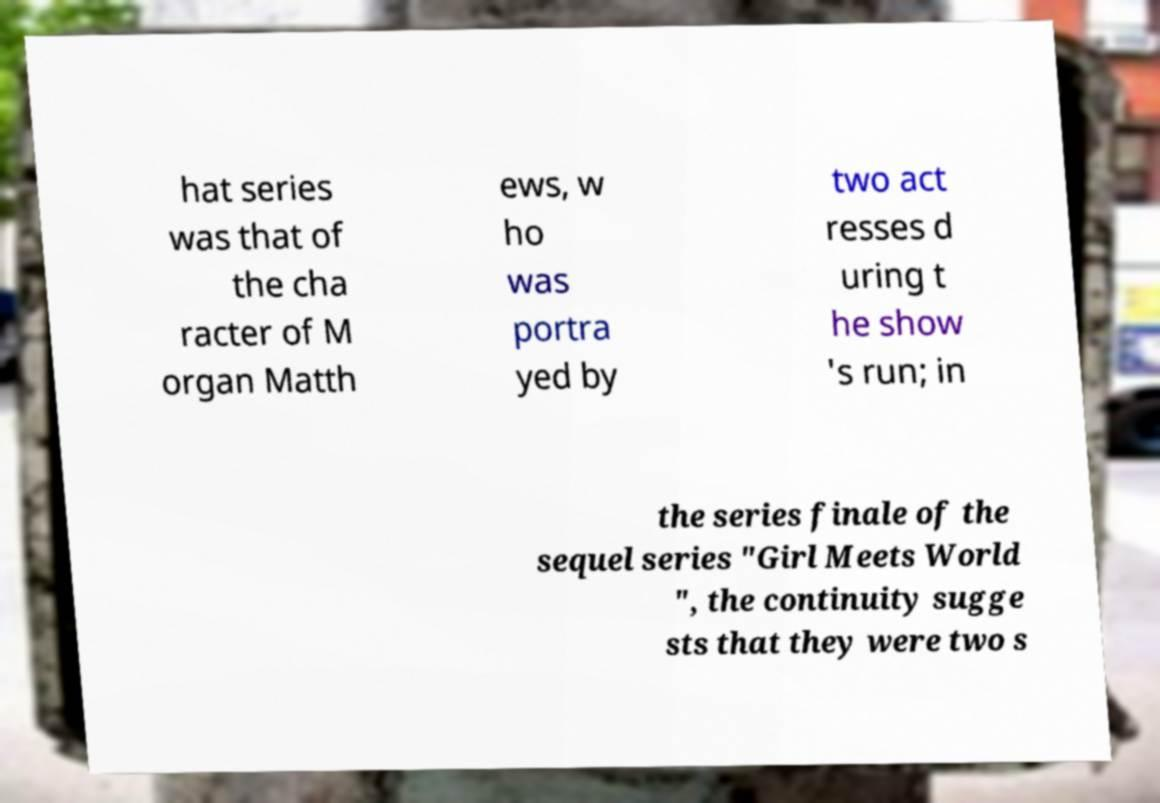Please read and relay the text visible in this image. What does it say? hat series was that of the cha racter of M organ Matth ews, w ho was portra yed by two act resses d uring t he show 's run; in the series finale of the sequel series "Girl Meets World ", the continuity sugge sts that they were two s 